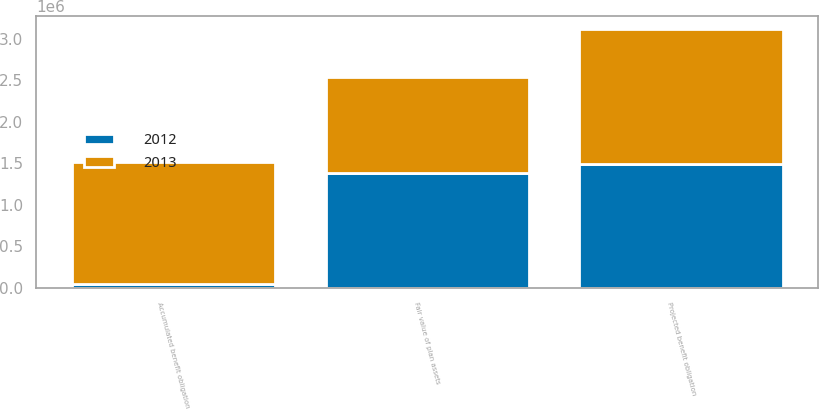<chart> <loc_0><loc_0><loc_500><loc_500><stacked_bar_chart><ecel><fcel>Projected benefit obligation<fcel>Fair value of plan assets<fcel>Accumulated benefit obligation<nl><fcel>2012<fcel>1.494e+06<fcel>1.384e+06<fcel>43000<nl><fcel>2013<fcel>1.621e+06<fcel>1.158e+06<fcel>1.472e+06<nl></chart> 